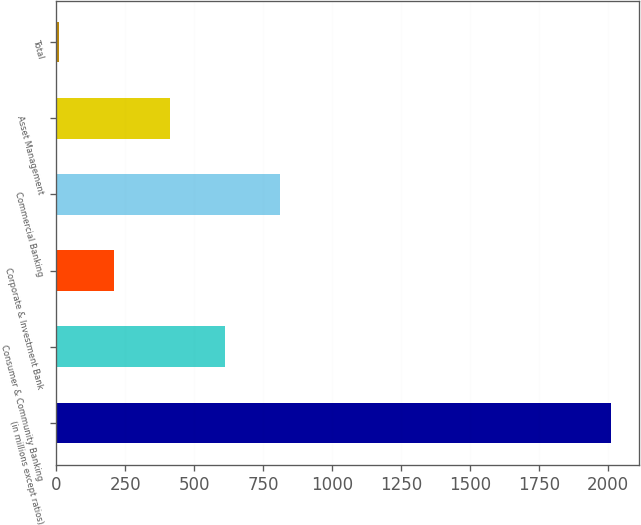Convert chart. <chart><loc_0><loc_0><loc_500><loc_500><bar_chart><fcel>(in millions except ratios)<fcel>Consumer & Community Banking<fcel>Corporate & Investment Bank<fcel>Commercial Banking<fcel>Asset Management<fcel>Total<nl><fcel>2012<fcel>611.3<fcel>211.1<fcel>811.4<fcel>411.2<fcel>11<nl></chart> 